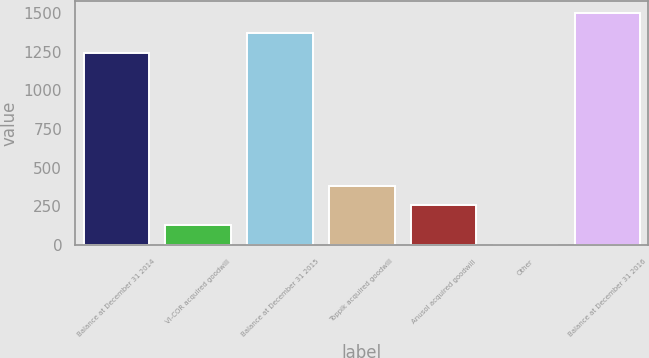<chart> <loc_0><loc_0><loc_500><loc_500><bar_chart><fcel>Balance at December 31 2014<fcel>VI-COR acquired goodwill<fcel>Balance at December 31 2015<fcel>Toppik acquired goodwill<fcel>Anusol acquired goodwill<fcel>Other<fcel>Balance at December 31 2016<nl><fcel>1242.2<fcel>128.73<fcel>1370.13<fcel>384.59<fcel>256.66<fcel>0.8<fcel>1498.06<nl></chart> 